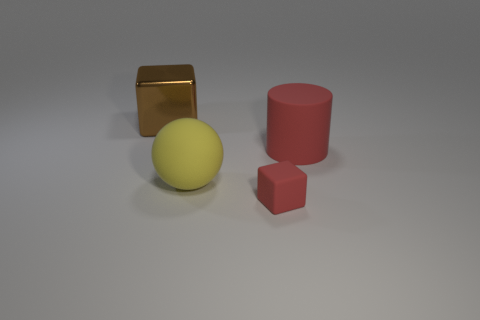How many yellow objects are spheres or large metallic balls?
Provide a short and direct response. 1. The cylinder has what color?
Offer a terse response. Red. What is the size of the red cylinder that is the same material as the sphere?
Give a very brief answer. Large. How many brown objects have the same shape as the tiny red thing?
Ensure brevity in your answer.  1. Is there anything else that has the same size as the red rubber block?
Give a very brief answer. No. There is a red matte object that is to the right of the block that is to the right of the brown cube; what size is it?
Your answer should be compact. Large. There is a cube that is the same size as the matte sphere; what material is it?
Offer a very short reply. Metal. Is there a big red object made of the same material as the large yellow object?
Your response must be concise. Yes. There is a rubber object behind the large thing that is in front of the red rubber thing behind the large yellow rubber ball; what color is it?
Ensure brevity in your answer.  Red. There is a large rubber object behind the large yellow ball; is it the same color as the object that is in front of the yellow thing?
Offer a terse response. Yes. 